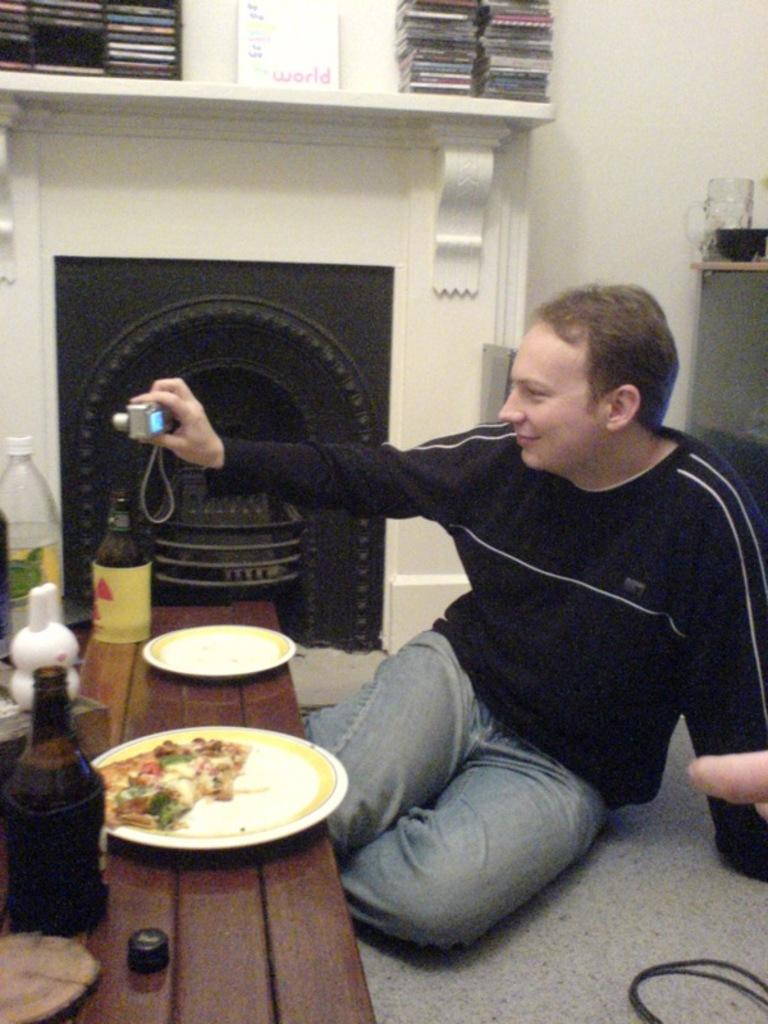<image>
Present a compact description of the photo's key features. A box reading world sits above a fireplace where a man is gathered for a meal. 